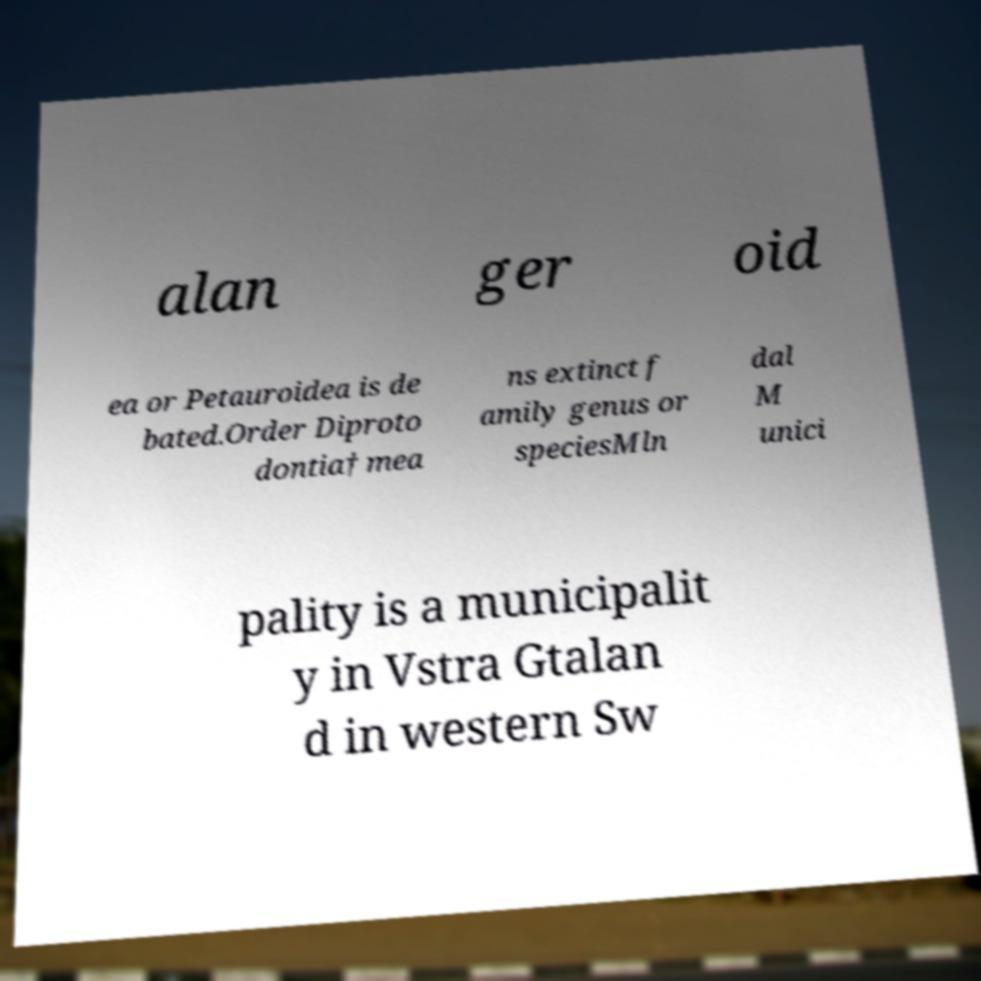What messages or text are displayed in this image? I need them in a readable, typed format. alan ger oid ea or Petauroidea is de bated.Order Diproto dontia† mea ns extinct f amily genus or speciesMln dal M unici pality is a municipalit y in Vstra Gtalan d in western Sw 